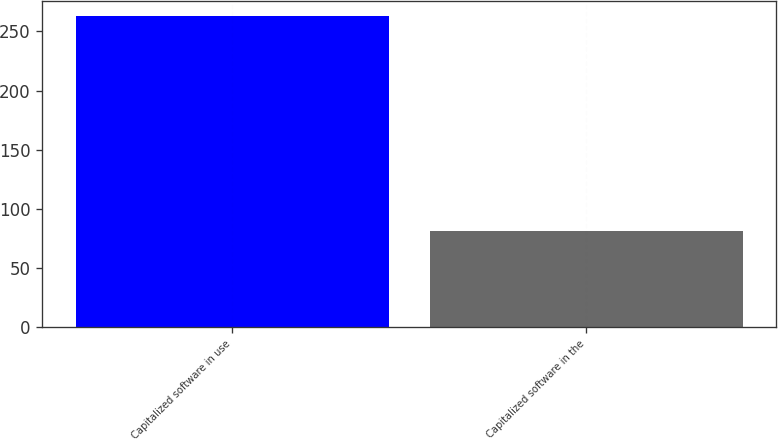Convert chart to OTSL. <chart><loc_0><loc_0><loc_500><loc_500><bar_chart><fcel>Capitalized software in use<fcel>Capitalized software in the<nl><fcel>263<fcel>81<nl></chart> 